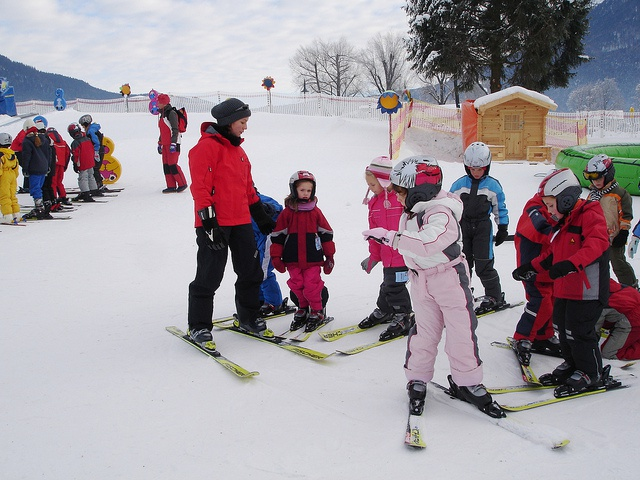Describe the objects in this image and their specific colors. I can see people in lightgray, darkgray, black, and gray tones, people in lightgray, black, and brown tones, people in lightgray, black, brown, maroon, and gray tones, people in lightgray, maroon, black, and brown tones, and people in lightgray, black, darkgray, and gray tones in this image. 